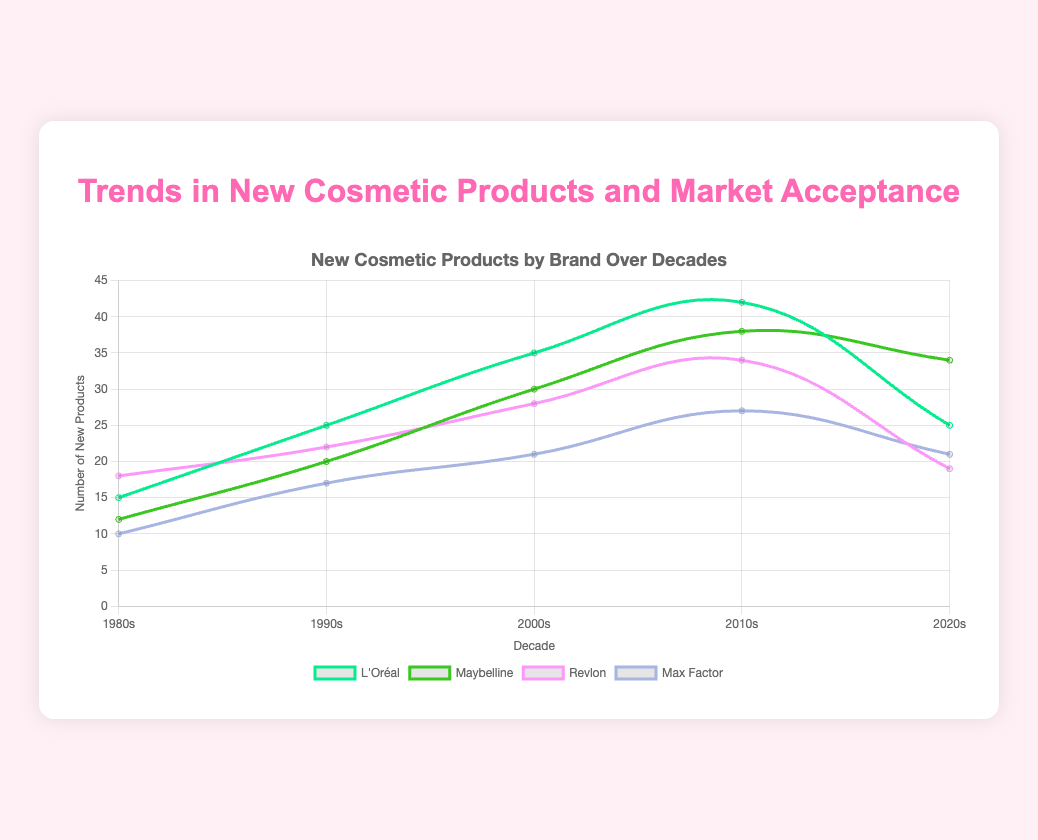What is the total number of new products introduced by L'Oréal from the 1980s to the 2020s? L'Oréal introduced 15 new products in the 1980s, 25 in the 1990s, 35 in the 2000s, 42 in the 2010s, and 25 in the 2020s. The total is 15 + 25 + 35 + 42 + 25 = 142
Answer: 142 Which brand had the highest market acceptance in the 2020s? By looking at the market acceptance values for the 2020s, L'Oréal has 95, Maybelline has 90, Revlon has 82, Max Factor has 78, and Smashbox has 89. L'Oréal has the highest market acceptance with a value of 95
Answer: L'Oréal How does the number of new products introduced by Maybelline in the 1990s compare to those introduced in the 2020s? In the 1990s, Maybelline introduced 20 new products. In the 2020s, Maybelline introduced 34 new products. So, Maybelline introduced 14 more products in the 2020s compared to the 1990s
Answer: 14 more in the 2020s What is the average market acceptance for Revlon over the four decades displayed? Revlon's market acceptance values are 57 in the 1980s, 65 in the 1990s, 75 in the 2000s, 80 in the 2010s, and 82 in the 2020s. The average is (57 + 65 + 75 + 80 + 82) / 5 = 359 / 5 = 71.8
Answer: 71.8 Between Max Factor and Smashbox, which brand saw a greater increase in the number of new products introduced from the 1980s to the 2020s? Max Factor increased from 10 new products in the 1980s to 21 in the 2020s, an increase of 11 products. Smashbox increased from 8 in the 1990s (not present in the 1980s) to 32 in the 2020s, an increase of 24 products. Smashbox saw a greater increase
Answer: Smashbox By how much did the market acceptance of L'Oréal improve from the 1980s to the 2020s? L'Oréal's market acceptance was 65 in the 1980s and improved to 95 in the 2020s. The improvement is 95 - 65 = 30
Answer: 30 Which brand introduced the fewest new products in the 2010s? In the 2010s, L'Oréal introduced 42 new products, Maybelline introduced 38, Revlon introduced 34, Max Factor introduced 27, and Smashbox introduced 30. Max Factor introduced the fewest new products with 27
Answer: Max Factor How did Smashbox's market acceptance in the 2000s compare to the 2010s? Smashbox had a market acceptance of 82 in the 2000s and 85 in the 2010s. The difference is 85 - 82 = 3, so the market acceptance increased by 3
Answer: Increased by 3 What is the overall trend in the number of new products introduced by Maybelline from the 1980s to the 2020s? Maybelline introduced 12 new products in the 1980s, 20 in the 1990s, 30 in the 2000s, 38 in the 2010s, and 34 in the 2020s. The general trend shows an increase over the decades from the 1980s to the 2010s, followed by a slight decrease in the 2020s
Answer: General increase till 2010s, then slight decrease 